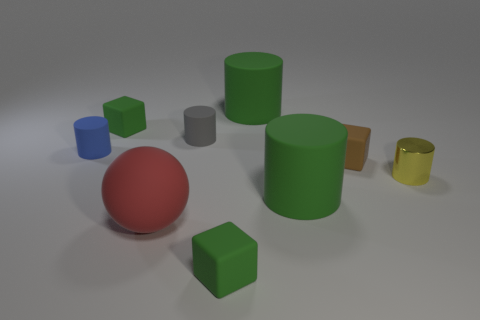Subtract all metal cylinders. How many cylinders are left? 4 Subtract 1 cylinders. How many cylinders are left? 4 Subtract all gray cylinders. How many cylinders are left? 4 Subtract all gray cylinders. Subtract all gray balls. How many cylinders are left? 4 Subtract all cylinders. How many objects are left? 4 Add 9 purple shiny things. How many purple shiny things exist? 9 Subtract 0 brown balls. How many objects are left? 9 Subtract all small yellow metallic cylinders. Subtract all large matte things. How many objects are left? 5 Add 5 large green things. How many large green things are left? 7 